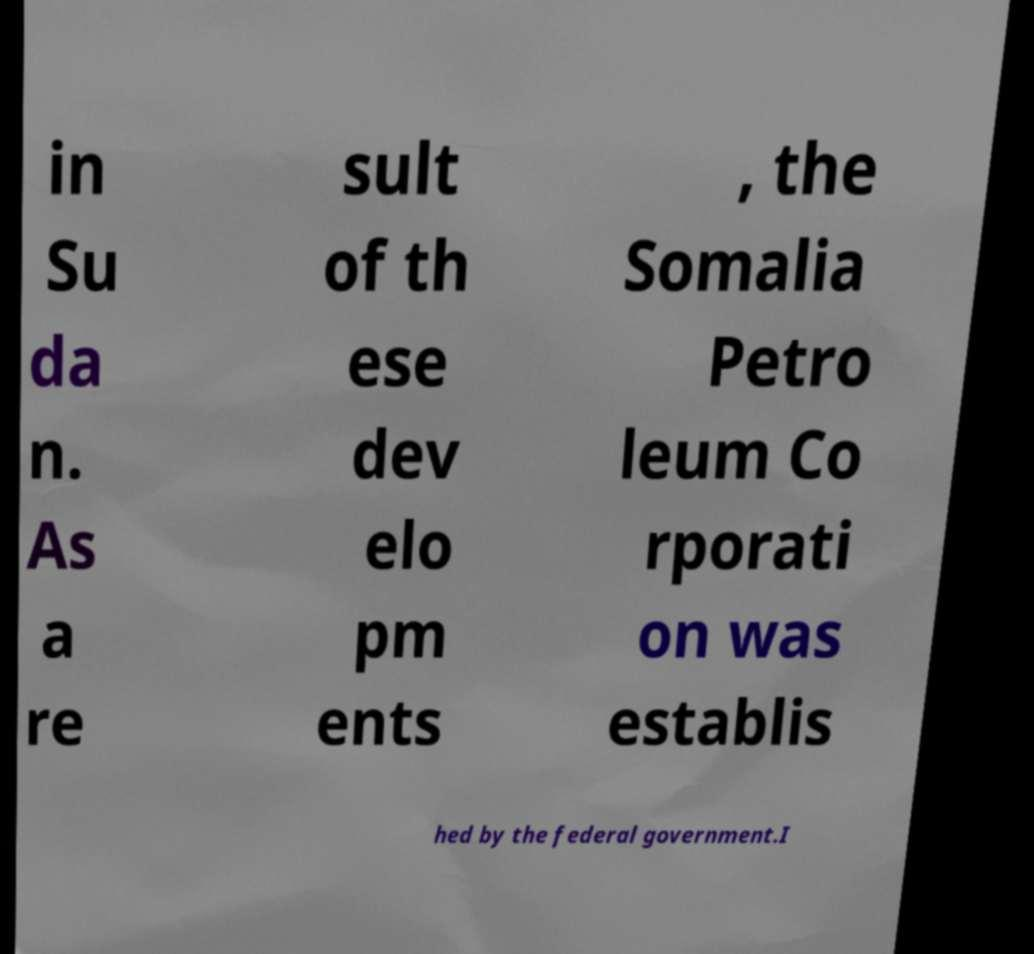Could you assist in decoding the text presented in this image and type it out clearly? in Su da n. As a re sult of th ese dev elo pm ents , the Somalia Petro leum Co rporati on was establis hed by the federal government.I 